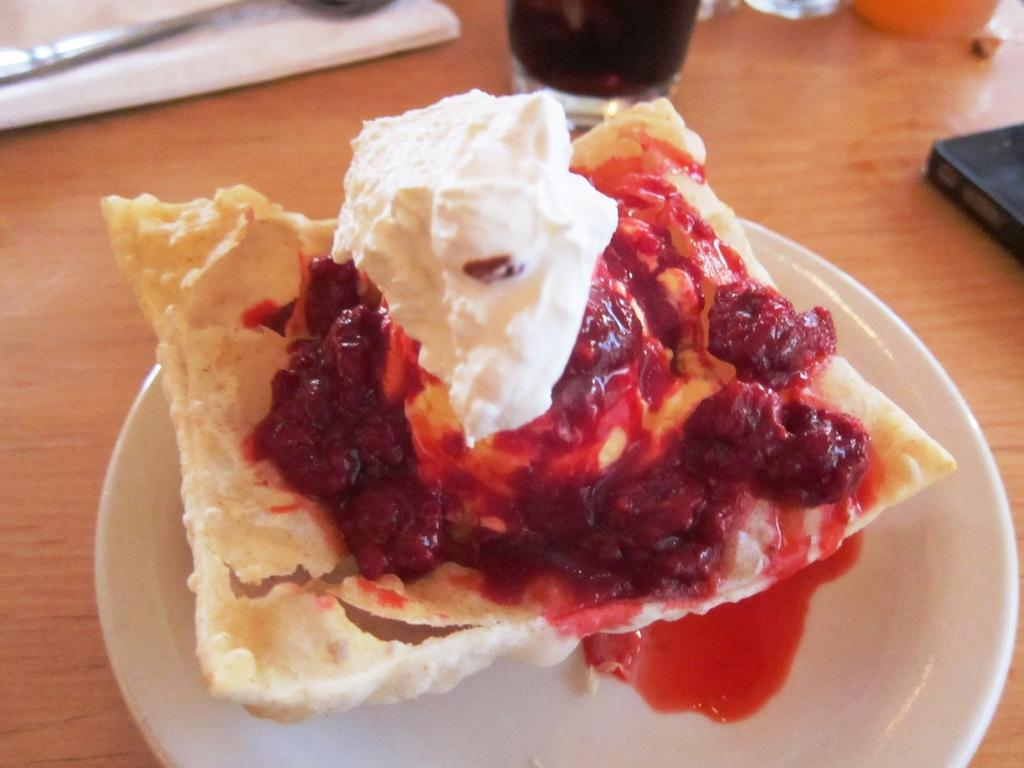What piece of furniture is in the image? There is a table in the image. How many plates are on the table? There are on the table. What is in the glass on the table? There is a glass of drink present on the table. What can be seen in the plates on the table? There is food visible in the plate, and there is sauce present in the plate. How many kittens are sitting on the table in the image? There are no kittens present in the image. What type of bread is visible in the plate? There is no bread visible in the plate; it contains food and sauce. 